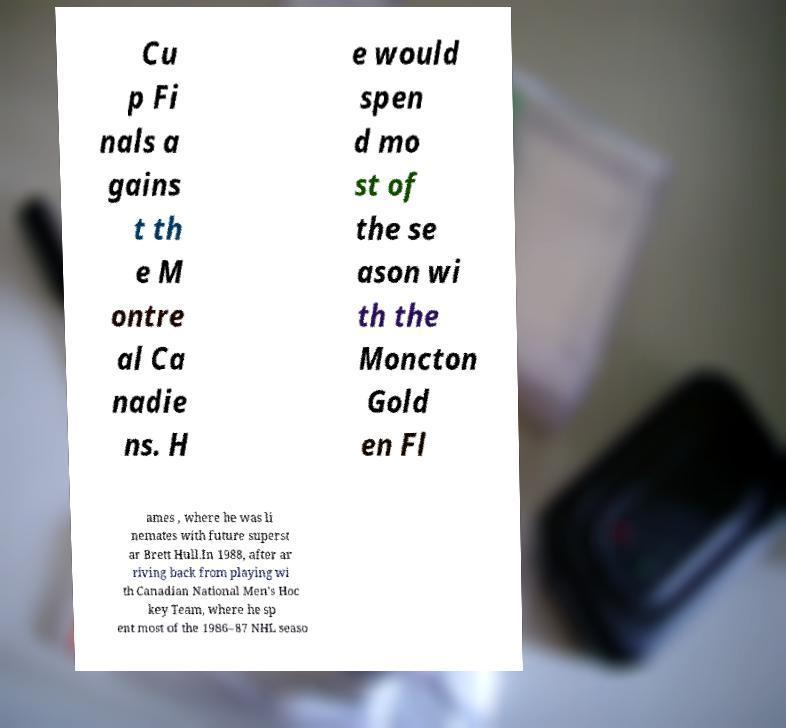Please identify and transcribe the text found in this image. Cu p Fi nals a gains t th e M ontre al Ca nadie ns. H e would spen d mo st of the se ason wi th the Moncton Gold en Fl ames , where he was li nemates with future superst ar Brett Hull.In 1988, after ar riving back from playing wi th Canadian National Men's Hoc key Team, where he sp ent most of the 1986–87 NHL seaso 